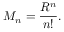<formula> <loc_0><loc_0><loc_500><loc_500>M _ { n } = { \frac { R ^ { n } } { n ! } } .</formula> 